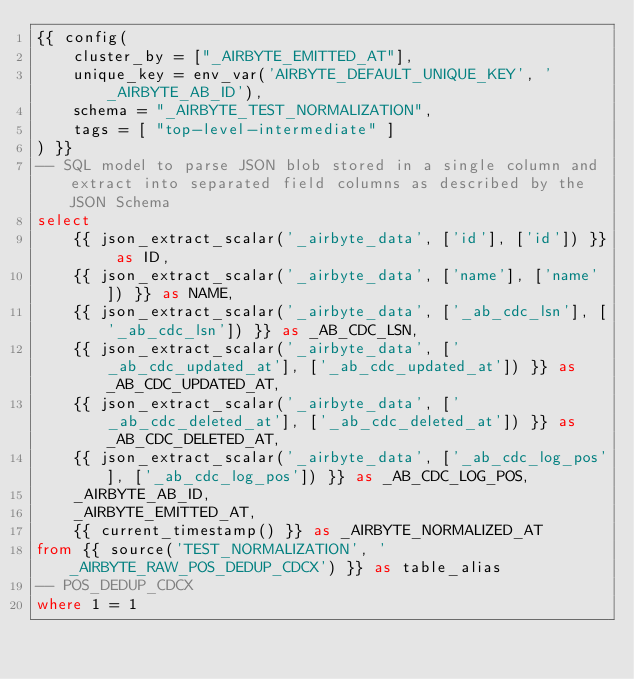<code> <loc_0><loc_0><loc_500><loc_500><_SQL_>{{ config(
    cluster_by = ["_AIRBYTE_EMITTED_AT"],
    unique_key = env_var('AIRBYTE_DEFAULT_UNIQUE_KEY', '_AIRBYTE_AB_ID'),
    schema = "_AIRBYTE_TEST_NORMALIZATION",
    tags = [ "top-level-intermediate" ]
) }}
-- SQL model to parse JSON blob stored in a single column and extract into separated field columns as described by the JSON Schema
select
    {{ json_extract_scalar('_airbyte_data', ['id'], ['id']) }} as ID,
    {{ json_extract_scalar('_airbyte_data', ['name'], ['name']) }} as NAME,
    {{ json_extract_scalar('_airbyte_data', ['_ab_cdc_lsn'], ['_ab_cdc_lsn']) }} as _AB_CDC_LSN,
    {{ json_extract_scalar('_airbyte_data', ['_ab_cdc_updated_at'], ['_ab_cdc_updated_at']) }} as _AB_CDC_UPDATED_AT,
    {{ json_extract_scalar('_airbyte_data', ['_ab_cdc_deleted_at'], ['_ab_cdc_deleted_at']) }} as _AB_CDC_DELETED_AT,
    {{ json_extract_scalar('_airbyte_data', ['_ab_cdc_log_pos'], ['_ab_cdc_log_pos']) }} as _AB_CDC_LOG_POS,
    _AIRBYTE_AB_ID,
    _AIRBYTE_EMITTED_AT,
    {{ current_timestamp() }} as _AIRBYTE_NORMALIZED_AT
from {{ source('TEST_NORMALIZATION', '_AIRBYTE_RAW_POS_DEDUP_CDCX') }} as table_alias
-- POS_DEDUP_CDCX
where 1 = 1

</code> 